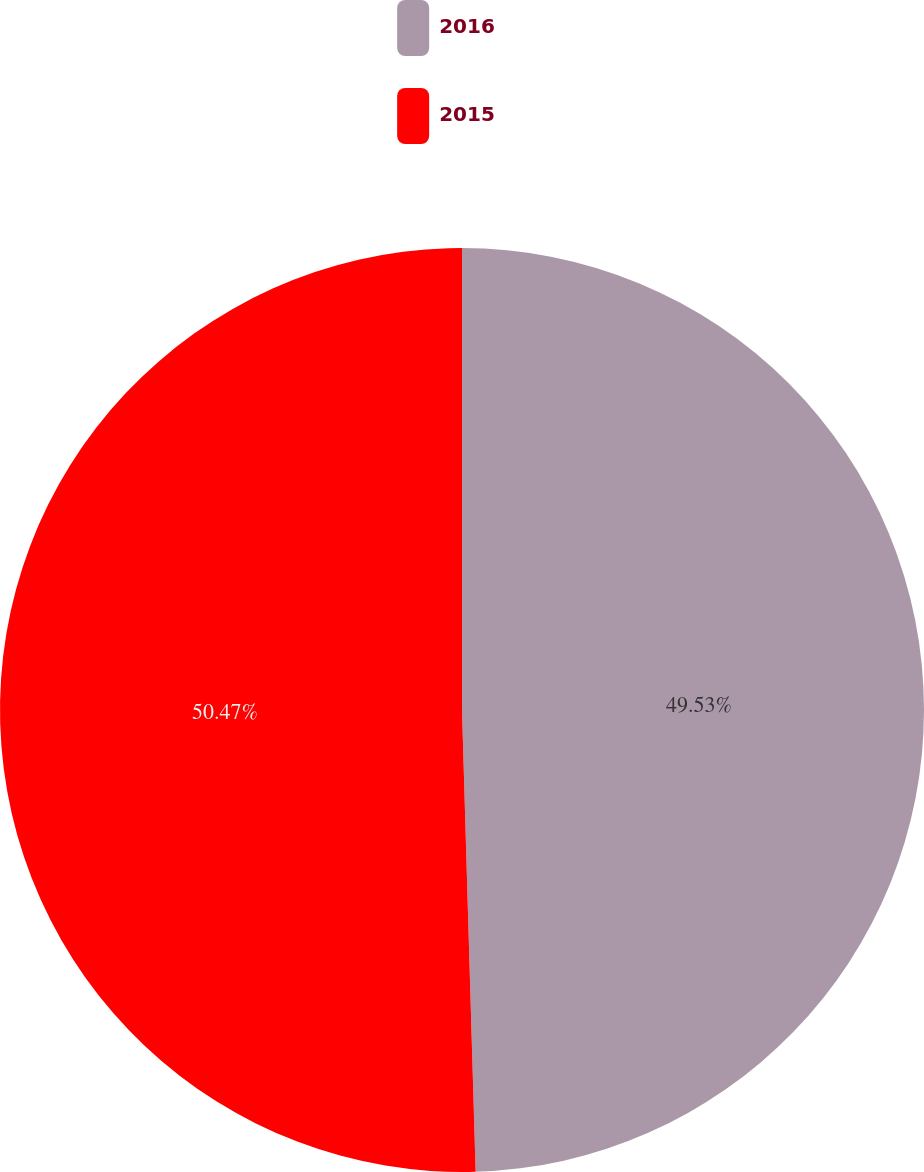Convert chart. <chart><loc_0><loc_0><loc_500><loc_500><pie_chart><fcel>2016<fcel>2015<nl><fcel>49.53%<fcel>50.47%<nl></chart> 